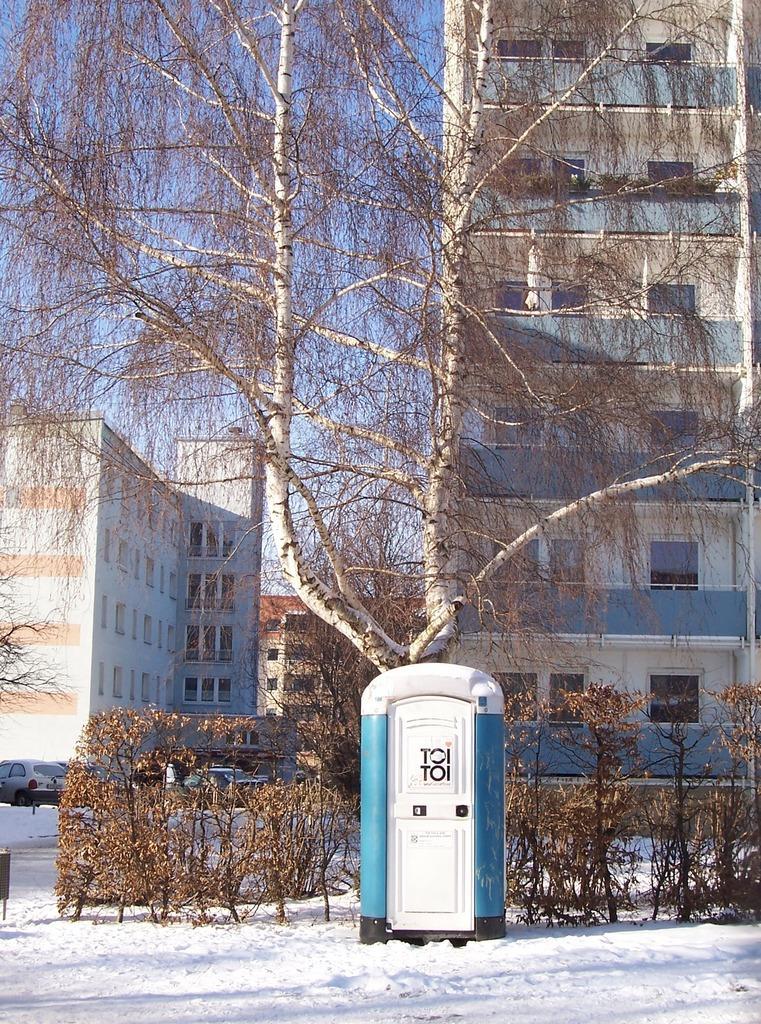Describe this image in one or two sentences. There is an object on the snow and there are few dried trees,plants and buildings in the background. 